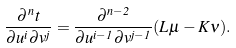<formula> <loc_0><loc_0><loc_500><loc_500>\frac { \partial ^ { n } t } { \partial u ^ { i } \partial v ^ { j } } = \frac { \partial ^ { n - 2 } } { \partial u ^ { i - 1 } \partial v ^ { j - 1 } } ( L \mu - K \nu ) .</formula> 